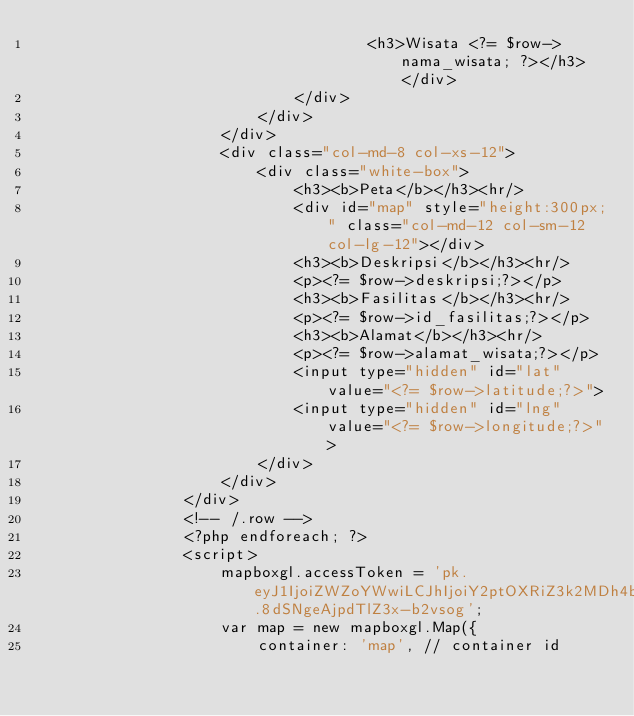<code> <loc_0><loc_0><loc_500><loc_500><_PHP_>                                    <h3>Wisata <?= $row->nama_wisata; ?></h3> </div>
                            </div>
                        </div>
                    </div>
                    <div class="col-md-8 col-xs-12">
                        <div class="white-box">
                            <h3><b>Peta</b></h3><hr/>
                            <div id="map" style="height:300px;" class="col-md-12 col-sm-12 col-lg-12"></div>
                            <h3><b>Deskripsi</b></h3><hr/>
                            <p><?= $row->deskripsi;?></p>
                            <h3><b>Fasilitas</b></h3><hr/>
                            <p><?= $row->id_fasilitas;?></p>
                            <h3><b>Alamat</b></h3><hr/>
                            <p><?= $row->alamat_wisata;?></p>
                            <input type="hidden" id="lat" value="<?= $row->latitude;?>">
                            <input type="hidden" id="lng" value="<?= $row->longitude;?>">        
                        </div>
                    </div>
                </div>
                <!-- /.row -->
                <?php endforeach; ?>
                <script>
                    mapboxgl.accessToken = 'pk.eyJ1IjoiZWZoYWwiLCJhIjoiY2ptOXRiZ3k2MDh4bzNrbnljMjk5Z2d5aSJ9.8dSNgeAjpdTlZ3x-b2vsog';
                    var map = new mapboxgl.Map({
                        container: 'map', // container id</code> 